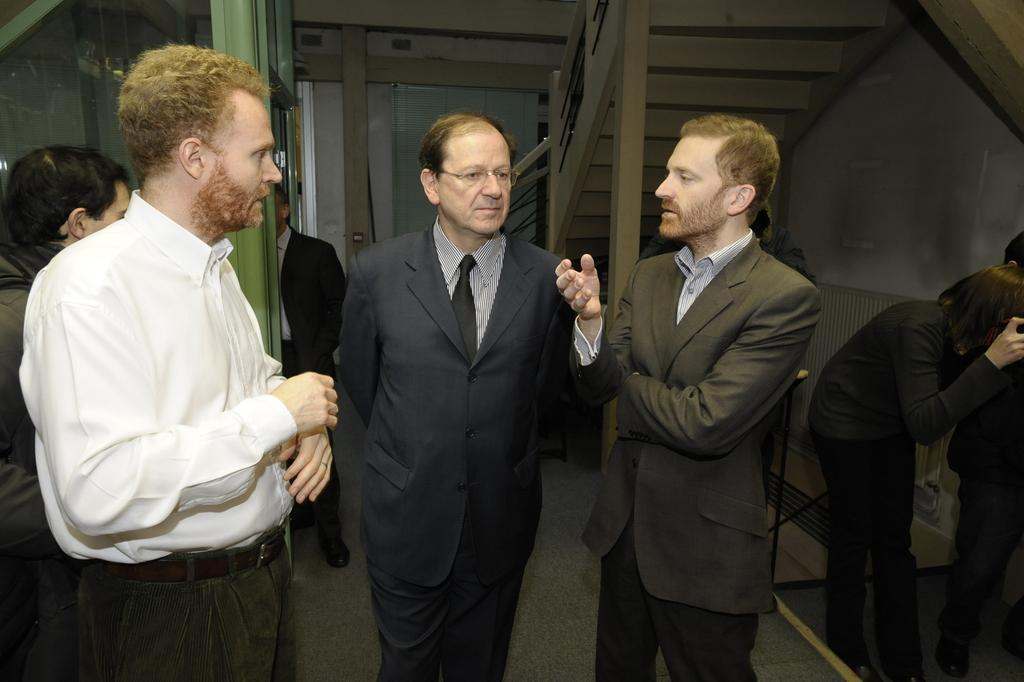What can be observed about the people in the image? There are people standing in the image. What architectural feature is present on the right side of the image? There is a staircase on the right side of the image. What is the person on the right side holding? The person on the right side is holding something. What type of clothing are two persons in the front wearing? Two persons in the front are wearing suits. How many children are visible in the image? There are no children present in the image; it features adults standing and wearing suits. 